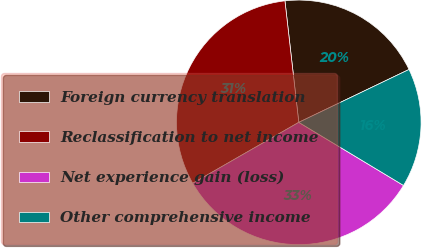Convert chart to OTSL. <chart><loc_0><loc_0><loc_500><loc_500><pie_chart><fcel>Foreign currency translation<fcel>Reclassification to net income<fcel>Net experience gain (loss)<fcel>Other comprehensive income<nl><fcel>19.69%<fcel>31.5%<fcel>33.07%<fcel>15.75%<nl></chart> 